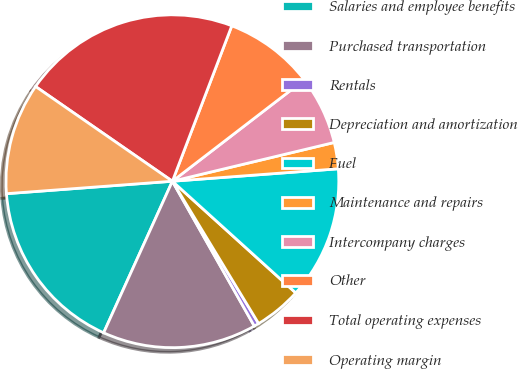<chart> <loc_0><loc_0><loc_500><loc_500><pie_chart><fcel>Salaries and employee benefits<fcel>Purchased transportation<fcel>Rentals<fcel>Depreciation and amortization<fcel>Fuel<fcel>Maintenance and repairs<fcel>Intercompany charges<fcel>Other<fcel>Total operating expenses<fcel>Operating margin<nl><fcel>17.03%<fcel>14.97%<fcel>0.48%<fcel>4.62%<fcel>12.9%<fcel>2.55%<fcel>6.69%<fcel>8.76%<fcel>21.17%<fcel>10.83%<nl></chart> 